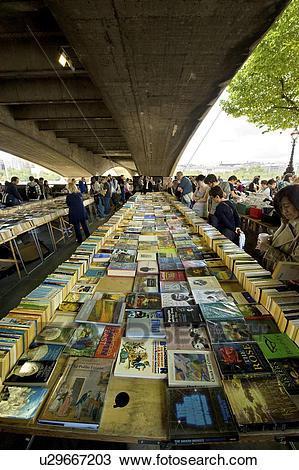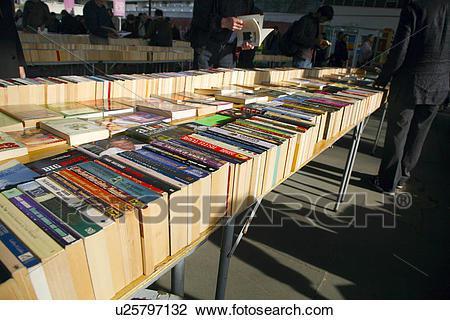The first image is the image on the left, the second image is the image on the right. For the images displayed, is the sentence "The left image is a head-on view of a long display of books under a narrow overhead structure, with the books stacked flat in several center rows, flanked on each side by a row of books stacked vertically, with people browsing on either side." factually correct? Answer yes or no. Yes. The first image is the image on the left, the second image is the image on the right. Analyze the images presented: Is the assertion "There are fewer than ten people in the image on the left." valid? Answer yes or no. No. 